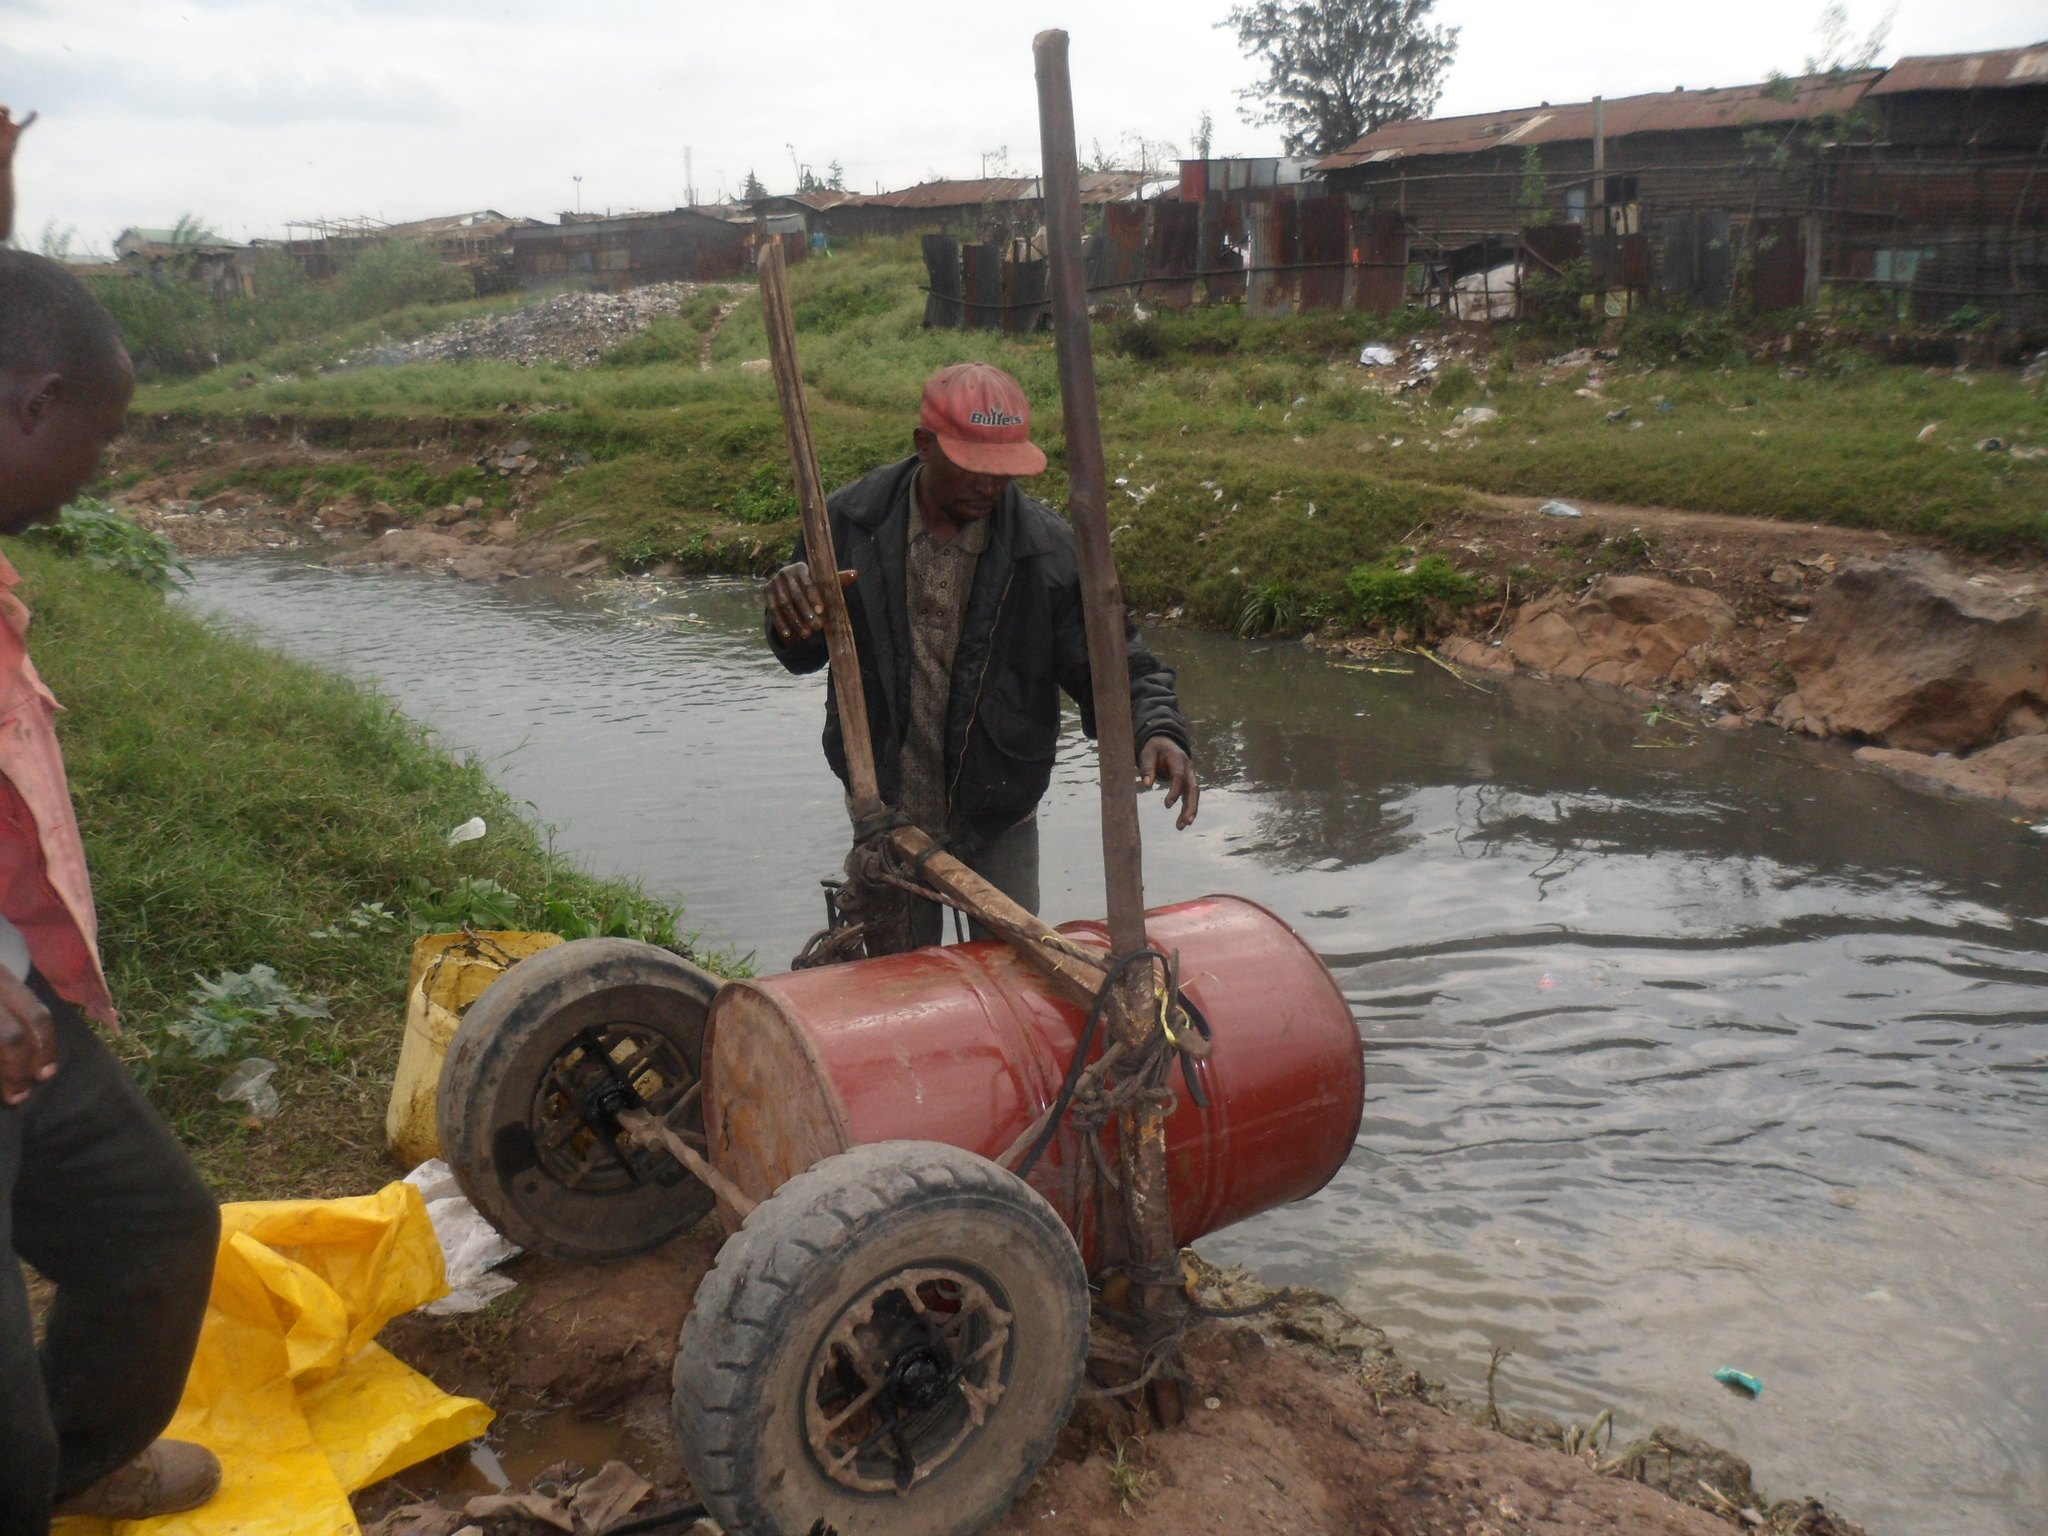Please provide a concise description of this image. In this image, we can see two persons. Here a person is holding a rods. At the bottom, we can see wheels, barrel, ropes, yellow sheet and water. Background we can see grass, plants, rocks, houses, trees, few objects and sky. 